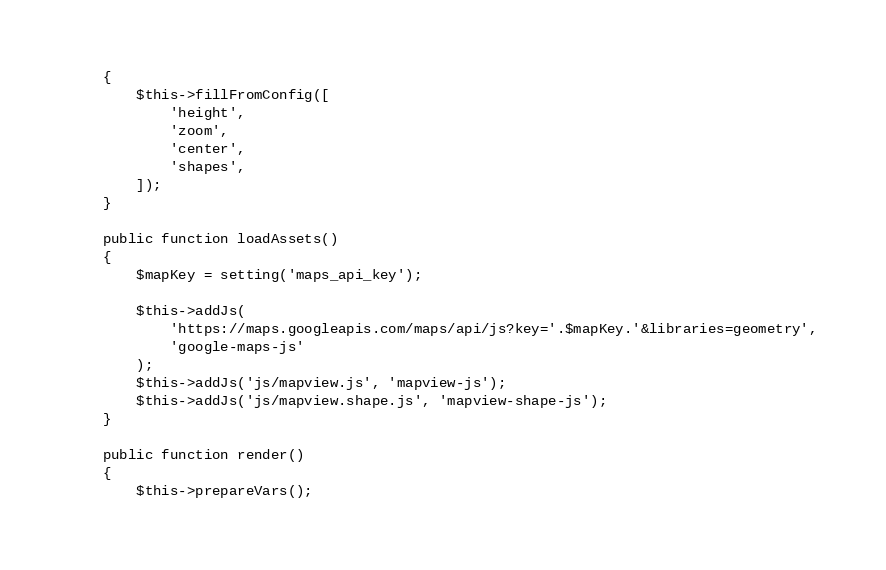<code> <loc_0><loc_0><loc_500><loc_500><_PHP_>    {
        $this->fillFromConfig([
            'height',
            'zoom',
            'center',
            'shapes',
        ]);
    }

    public function loadAssets()
    {
        $mapKey = setting('maps_api_key');

        $this->addJs(
            'https://maps.googleapis.com/maps/api/js?key='.$mapKey.'&libraries=geometry',
            'google-maps-js'
        );
        $this->addJs('js/mapview.js', 'mapview-js');
        $this->addJs('js/mapview.shape.js', 'mapview-shape-js');
    }

    public function render()
    {
        $this->prepareVars();
</code> 